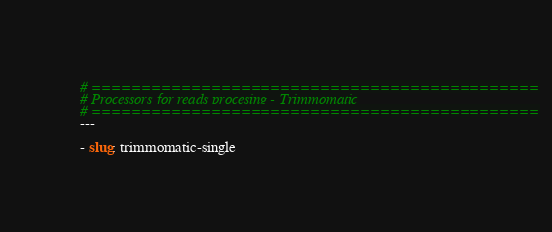<code> <loc_0><loc_0><loc_500><loc_500><_YAML_># =============================================
# Processors for reads procesing - Trimmomatic
# =============================================
---

- slug: trimmomatic-single</code> 